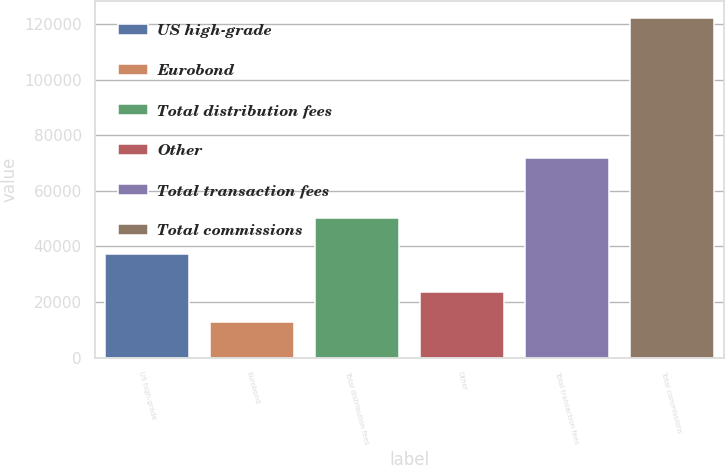Convert chart to OTSL. <chart><loc_0><loc_0><loc_500><loc_500><bar_chart><fcel>US high-grade<fcel>Eurobond<fcel>Total distribution fees<fcel>Other<fcel>Total transaction fees<fcel>Total commissions<nl><fcel>37467<fcel>12693<fcel>50160<fcel>23641.7<fcel>72020<fcel>122180<nl></chart> 